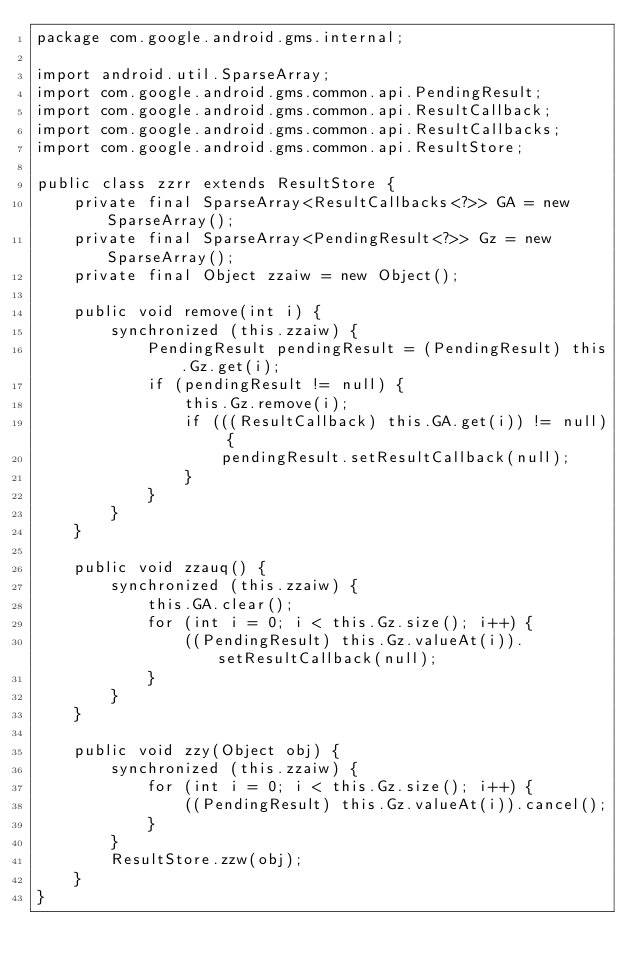Convert code to text. <code><loc_0><loc_0><loc_500><loc_500><_Java_>package com.google.android.gms.internal;

import android.util.SparseArray;
import com.google.android.gms.common.api.PendingResult;
import com.google.android.gms.common.api.ResultCallback;
import com.google.android.gms.common.api.ResultCallbacks;
import com.google.android.gms.common.api.ResultStore;

public class zzrr extends ResultStore {
    private final SparseArray<ResultCallbacks<?>> GA = new SparseArray();
    private final SparseArray<PendingResult<?>> Gz = new SparseArray();
    private final Object zzaiw = new Object();

    public void remove(int i) {
        synchronized (this.zzaiw) {
            PendingResult pendingResult = (PendingResult) this.Gz.get(i);
            if (pendingResult != null) {
                this.Gz.remove(i);
                if (((ResultCallback) this.GA.get(i)) != null) {
                    pendingResult.setResultCallback(null);
                }
            }
        }
    }

    public void zzauq() {
        synchronized (this.zzaiw) {
            this.GA.clear();
            for (int i = 0; i < this.Gz.size(); i++) {
                ((PendingResult) this.Gz.valueAt(i)).setResultCallback(null);
            }
        }
    }

    public void zzy(Object obj) {
        synchronized (this.zzaiw) {
            for (int i = 0; i < this.Gz.size(); i++) {
                ((PendingResult) this.Gz.valueAt(i)).cancel();
            }
        }
        ResultStore.zzw(obj);
    }
}
</code> 